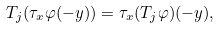Convert formula to latex. <formula><loc_0><loc_0><loc_500><loc_500>T _ { j } ( \tau _ { x } \varphi ( - y ) ) = \tau _ { x } ( T _ { j } \varphi ) ( - y ) ,</formula> 